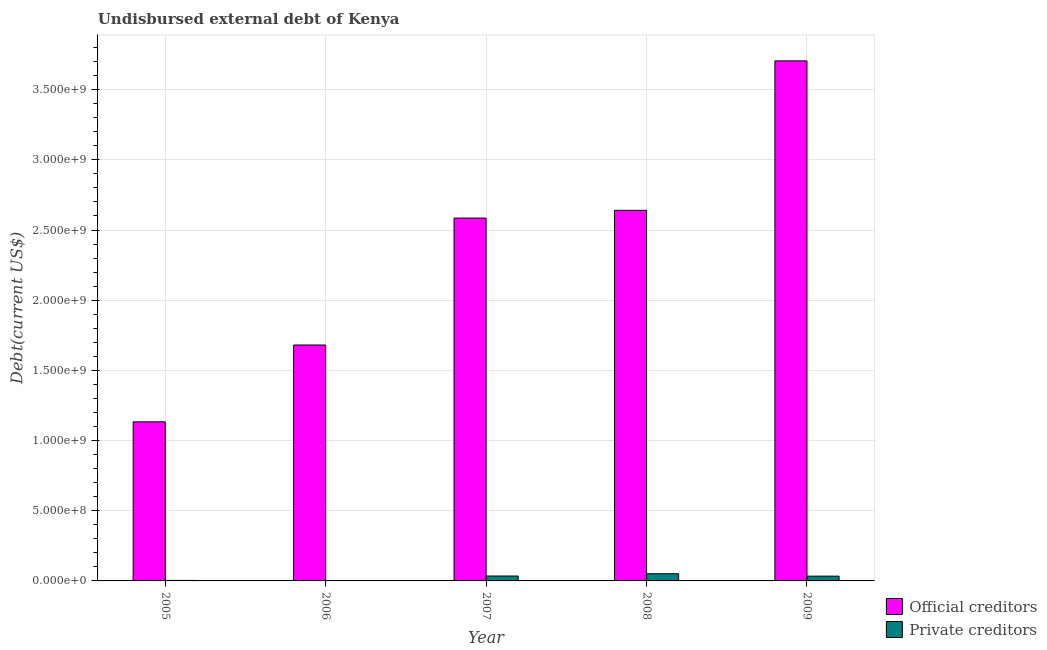How many groups of bars are there?
Provide a succinct answer. 5. Are the number of bars per tick equal to the number of legend labels?
Your answer should be compact. Yes. How many bars are there on the 3rd tick from the left?
Your answer should be very brief. 2. What is the label of the 3rd group of bars from the left?
Offer a very short reply. 2007. In how many cases, is the number of bars for a given year not equal to the number of legend labels?
Give a very brief answer. 0. What is the undisbursed external debt of official creditors in 2009?
Make the answer very short. 3.70e+09. Across all years, what is the maximum undisbursed external debt of private creditors?
Your answer should be very brief. 5.12e+07. Across all years, what is the minimum undisbursed external debt of official creditors?
Keep it short and to the point. 1.13e+09. In which year was the undisbursed external debt of official creditors maximum?
Ensure brevity in your answer.  2009. What is the total undisbursed external debt of official creditors in the graph?
Ensure brevity in your answer.  1.17e+1. What is the difference between the undisbursed external debt of official creditors in 2008 and that in 2009?
Your answer should be very brief. -1.06e+09. What is the difference between the undisbursed external debt of private creditors in 2005 and the undisbursed external debt of official creditors in 2006?
Provide a short and direct response. 2.45e+06. What is the average undisbursed external debt of official creditors per year?
Offer a very short reply. 2.35e+09. In how many years, is the undisbursed external debt of private creditors greater than 1800000000 US$?
Offer a very short reply. 0. What is the ratio of the undisbursed external debt of official creditors in 2006 to that in 2008?
Make the answer very short. 0.64. Is the undisbursed external debt of official creditors in 2007 less than that in 2009?
Offer a terse response. Yes. What is the difference between the highest and the second highest undisbursed external debt of official creditors?
Your answer should be compact. 1.06e+09. What is the difference between the highest and the lowest undisbursed external debt of official creditors?
Keep it short and to the point. 2.57e+09. In how many years, is the undisbursed external debt of official creditors greater than the average undisbursed external debt of official creditors taken over all years?
Your answer should be compact. 3. Is the sum of the undisbursed external debt of private creditors in 2006 and 2009 greater than the maximum undisbursed external debt of official creditors across all years?
Your answer should be compact. No. What does the 2nd bar from the left in 2007 represents?
Provide a short and direct response. Private creditors. What does the 2nd bar from the right in 2006 represents?
Offer a very short reply. Official creditors. Are all the bars in the graph horizontal?
Offer a terse response. No. What is the difference between two consecutive major ticks on the Y-axis?
Your response must be concise. 5.00e+08. Are the values on the major ticks of Y-axis written in scientific E-notation?
Offer a very short reply. Yes. Does the graph contain any zero values?
Provide a short and direct response. No. How are the legend labels stacked?
Keep it short and to the point. Vertical. What is the title of the graph?
Make the answer very short. Undisbursed external debt of Kenya. Does "Highest 10% of population" appear as one of the legend labels in the graph?
Make the answer very short. No. What is the label or title of the Y-axis?
Offer a very short reply. Debt(current US$). What is the Debt(current US$) in Official creditors in 2005?
Your answer should be very brief. 1.13e+09. What is the Debt(current US$) in Private creditors in 2005?
Provide a short and direct response. 3.59e+06. What is the Debt(current US$) of Official creditors in 2006?
Offer a terse response. 1.68e+09. What is the Debt(current US$) of Private creditors in 2006?
Offer a very short reply. 1.14e+06. What is the Debt(current US$) of Official creditors in 2007?
Ensure brevity in your answer.  2.58e+09. What is the Debt(current US$) in Private creditors in 2007?
Offer a terse response. 3.49e+07. What is the Debt(current US$) of Official creditors in 2008?
Make the answer very short. 2.64e+09. What is the Debt(current US$) of Private creditors in 2008?
Offer a terse response. 5.12e+07. What is the Debt(current US$) in Official creditors in 2009?
Keep it short and to the point. 3.70e+09. What is the Debt(current US$) in Private creditors in 2009?
Provide a succinct answer. 3.40e+07. Across all years, what is the maximum Debt(current US$) of Official creditors?
Your response must be concise. 3.70e+09. Across all years, what is the maximum Debt(current US$) in Private creditors?
Give a very brief answer. 5.12e+07. Across all years, what is the minimum Debt(current US$) in Official creditors?
Provide a succinct answer. 1.13e+09. Across all years, what is the minimum Debt(current US$) of Private creditors?
Offer a very short reply. 1.14e+06. What is the total Debt(current US$) of Official creditors in the graph?
Ensure brevity in your answer.  1.17e+1. What is the total Debt(current US$) in Private creditors in the graph?
Provide a short and direct response. 1.25e+08. What is the difference between the Debt(current US$) of Official creditors in 2005 and that in 2006?
Your answer should be compact. -5.47e+08. What is the difference between the Debt(current US$) of Private creditors in 2005 and that in 2006?
Give a very brief answer. 2.45e+06. What is the difference between the Debt(current US$) of Official creditors in 2005 and that in 2007?
Your answer should be compact. -1.45e+09. What is the difference between the Debt(current US$) in Private creditors in 2005 and that in 2007?
Make the answer very short. -3.14e+07. What is the difference between the Debt(current US$) of Official creditors in 2005 and that in 2008?
Provide a succinct answer. -1.51e+09. What is the difference between the Debt(current US$) in Private creditors in 2005 and that in 2008?
Your answer should be compact. -4.76e+07. What is the difference between the Debt(current US$) of Official creditors in 2005 and that in 2009?
Offer a terse response. -2.57e+09. What is the difference between the Debt(current US$) of Private creditors in 2005 and that in 2009?
Offer a very short reply. -3.04e+07. What is the difference between the Debt(current US$) in Official creditors in 2006 and that in 2007?
Offer a terse response. -9.04e+08. What is the difference between the Debt(current US$) in Private creditors in 2006 and that in 2007?
Offer a very short reply. -3.38e+07. What is the difference between the Debt(current US$) of Official creditors in 2006 and that in 2008?
Give a very brief answer. -9.59e+08. What is the difference between the Debt(current US$) of Private creditors in 2006 and that in 2008?
Provide a succinct answer. -5.01e+07. What is the difference between the Debt(current US$) of Official creditors in 2006 and that in 2009?
Your answer should be compact. -2.02e+09. What is the difference between the Debt(current US$) in Private creditors in 2006 and that in 2009?
Make the answer very short. -3.28e+07. What is the difference between the Debt(current US$) of Official creditors in 2007 and that in 2008?
Your response must be concise. -5.50e+07. What is the difference between the Debt(current US$) of Private creditors in 2007 and that in 2008?
Offer a terse response. -1.63e+07. What is the difference between the Debt(current US$) in Official creditors in 2007 and that in 2009?
Your response must be concise. -1.12e+09. What is the difference between the Debt(current US$) in Private creditors in 2007 and that in 2009?
Offer a terse response. 9.62e+05. What is the difference between the Debt(current US$) of Official creditors in 2008 and that in 2009?
Provide a short and direct response. -1.06e+09. What is the difference between the Debt(current US$) of Private creditors in 2008 and that in 2009?
Keep it short and to the point. 1.72e+07. What is the difference between the Debt(current US$) of Official creditors in 2005 and the Debt(current US$) of Private creditors in 2006?
Provide a succinct answer. 1.13e+09. What is the difference between the Debt(current US$) of Official creditors in 2005 and the Debt(current US$) of Private creditors in 2007?
Offer a very short reply. 1.10e+09. What is the difference between the Debt(current US$) in Official creditors in 2005 and the Debt(current US$) in Private creditors in 2008?
Your answer should be very brief. 1.08e+09. What is the difference between the Debt(current US$) in Official creditors in 2005 and the Debt(current US$) in Private creditors in 2009?
Offer a very short reply. 1.10e+09. What is the difference between the Debt(current US$) in Official creditors in 2006 and the Debt(current US$) in Private creditors in 2007?
Give a very brief answer. 1.65e+09. What is the difference between the Debt(current US$) in Official creditors in 2006 and the Debt(current US$) in Private creditors in 2008?
Your response must be concise. 1.63e+09. What is the difference between the Debt(current US$) in Official creditors in 2006 and the Debt(current US$) in Private creditors in 2009?
Your answer should be very brief. 1.65e+09. What is the difference between the Debt(current US$) of Official creditors in 2007 and the Debt(current US$) of Private creditors in 2008?
Offer a very short reply. 2.53e+09. What is the difference between the Debt(current US$) of Official creditors in 2007 and the Debt(current US$) of Private creditors in 2009?
Provide a short and direct response. 2.55e+09. What is the difference between the Debt(current US$) of Official creditors in 2008 and the Debt(current US$) of Private creditors in 2009?
Give a very brief answer. 2.61e+09. What is the average Debt(current US$) of Official creditors per year?
Your response must be concise. 2.35e+09. What is the average Debt(current US$) in Private creditors per year?
Keep it short and to the point. 2.50e+07. In the year 2005, what is the difference between the Debt(current US$) in Official creditors and Debt(current US$) in Private creditors?
Ensure brevity in your answer.  1.13e+09. In the year 2006, what is the difference between the Debt(current US$) in Official creditors and Debt(current US$) in Private creditors?
Provide a short and direct response. 1.68e+09. In the year 2007, what is the difference between the Debt(current US$) of Official creditors and Debt(current US$) of Private creditors?
Provide a short and direct response. 2.55e+09. In the year 2008, what is the difference between the Debt(current US$) of Official creditors and Debt(current US$) of Private creditors?
Your response must be concise. 2.59e+09. In the year 2009, what is the difference between the Debt(current US$) in Official creditors and Debt(current US$) in Private creditors?
Your response must be concise. 3.67e+09. What is the ratio of the Debt(current US$) of Official creditors in 2005 to that in 2006?
Ensure brevity in your answer.  0.67. What is the ratio of the Debt(current US$) in Private creditors in 2005 to that in 2006?
Ensure brevity in your answer.  3.15. What is the ratio of the Debt(current US$) in Official creditors in 2005 to that in 2007?
Offer a very short reply. 0.44. What is the ratio of the Debt(current US$) of Private creditors in 2005 to that in 2007?
Ensure brevity in your answer.  0.1. What is the ratio of the Debt(current US$) in Official creditors in 2005 to that in 2008?
Your answer should be very brief. 0.43. What is the ratio of the Debt(current US$) in Private creditors in 2005 to that in 2008?
Offer a terse response. 0.07. What is the ratio of the Debt(current US$) in Official creditors in 2005 to that in 2009?
Your answer should be compact. 0.31. What is the ratio of the Debt(current US$) in Private creditors in 2005 to that in 2009?
Offer a terse response. 0.11. What is the ratio of the Debt(current US$) in Official creditors in 2006 to that in 2007?
Your response must be concise. 0.65. What is the ratio of the Debt(current US$) of Private creditors in 2006 to that in 2007?
Keep it short and to the point. 0.03. What is the ratio of the Debt(current US$) in Official creditors in 2006 to that in 2008?
Ensure brevity in your answer.  0.64. What is the ratio of the Debt(current US$) in Private creditors in 2006 to that in 2008?
Give a very brief answer. 0.02. What is the ratio of the Debt(current US$) of Official creditors in 2006 to that in 2009?
Your response must be concise. 0.45. What is the ratio of the Debt(current US$) in Private creditors in 2006 to that in 2009?
Your answer should be very brief. 0.03. What is the ratio of the Debt(current US$) of Official creditors in 2007 to that in 2008?
Your answer should be compact. 0.98. What is the ratio of the Debt(current US$) of Private creditors in 2007 to that in 2008?
Offer a terse response. 0.68. What is the ratio of the Debt(current US$) of Official creditors in 2007 to that in 2009?
Offer a very short reply. 0.7. What is the ratio of the Debt(current US$) of Private creditors in 2007 to that in 2009?
Provide a short and direct response. 1.03. What is the ratio of the Debt(current US$) in Official creditors in 2008 to that in 2009?
Your answer should be compact. 0.71. What is the ratio of the Debt(current US$) of Private creditors in 2008 to that in 2009?
Make the answer very short. 1.51. What is the difference between the highest and the second highest Debt(current US$) in Official creditors?
Offer a terse response. 1.06e+09. What is the difference between the highest and the second highest Debt(current US$) in Private creditors?
Your answer should be compact. 1.63e+07. What is the difference between the highest and the lowest Debt(current US$) in Official creditors?
Your response must be concise. 2.57e+09. What is the difference between the highest and the lowest Debt(current US$) of Private creditors?
Your answer should be compact. 5.01e+07. 